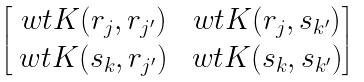<formula> <loc_0><loc_0><loc_500><loc_500>\begin{bmatrix} \ w t K ( r _ { j } , r _ { j ^ { \prime } } ) & \ w t K ( r _ { j } , s _ { k ^ { \prime } } ) \\ \ w t K ( s _ { k } , r _ { j ^ { \prime } } ) & \ w t K ( s _ { k } , s _ { k ^ { \prime } } ) \end{bmatrix}</formula> 